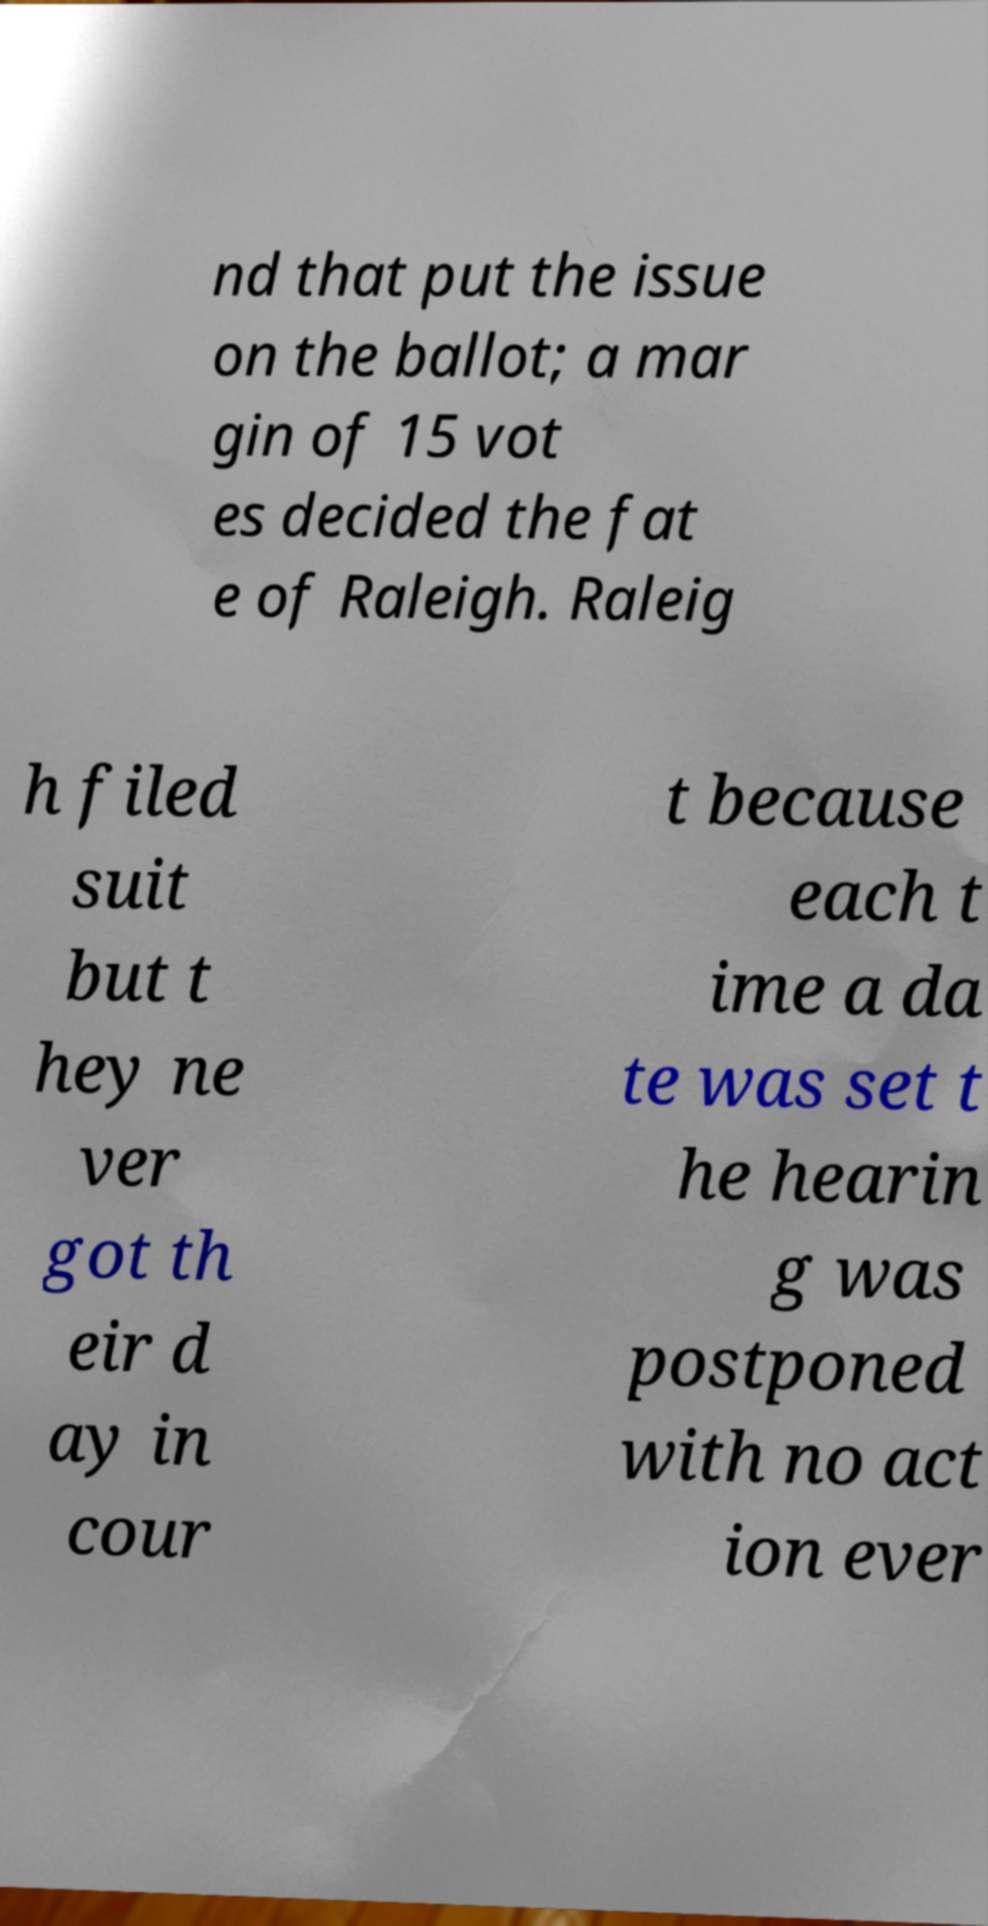I need the written content from this picture converted into text. Can you do that? nd that put the issue on the ballot; a mar gin of 15 vot es decided the fat e of Raleigh. Raleig h filed suit but t hey ne ver got th eir d ay in cour t because each t ime a da te was set t he hearin g was postponed with no act ion ever 